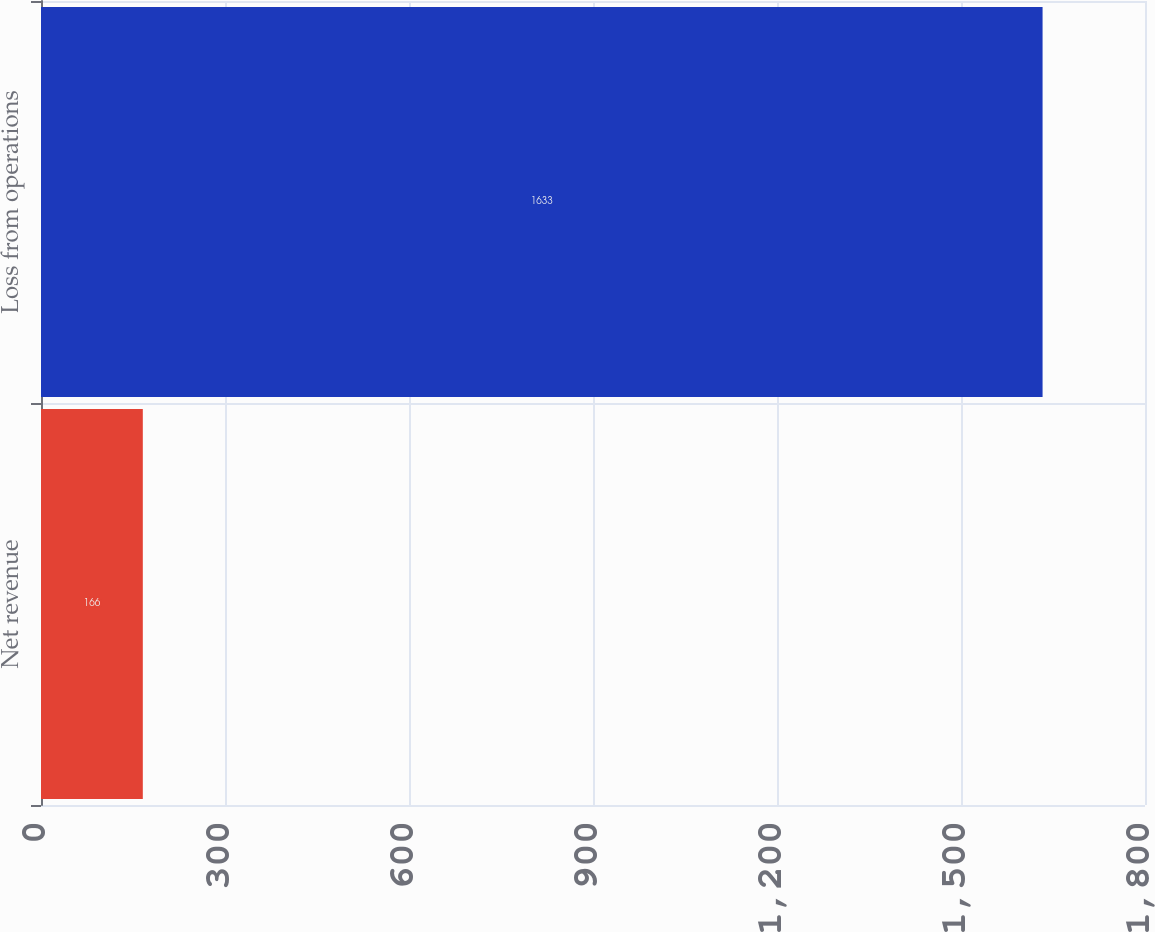Convert chart. <chart><loc_0><loc_0><loc_500><loc_500><bar_chart><fcel>Net revenue<fcel>Loss from operations<nl><fcel>166<fcel>1633<nl></chart> 